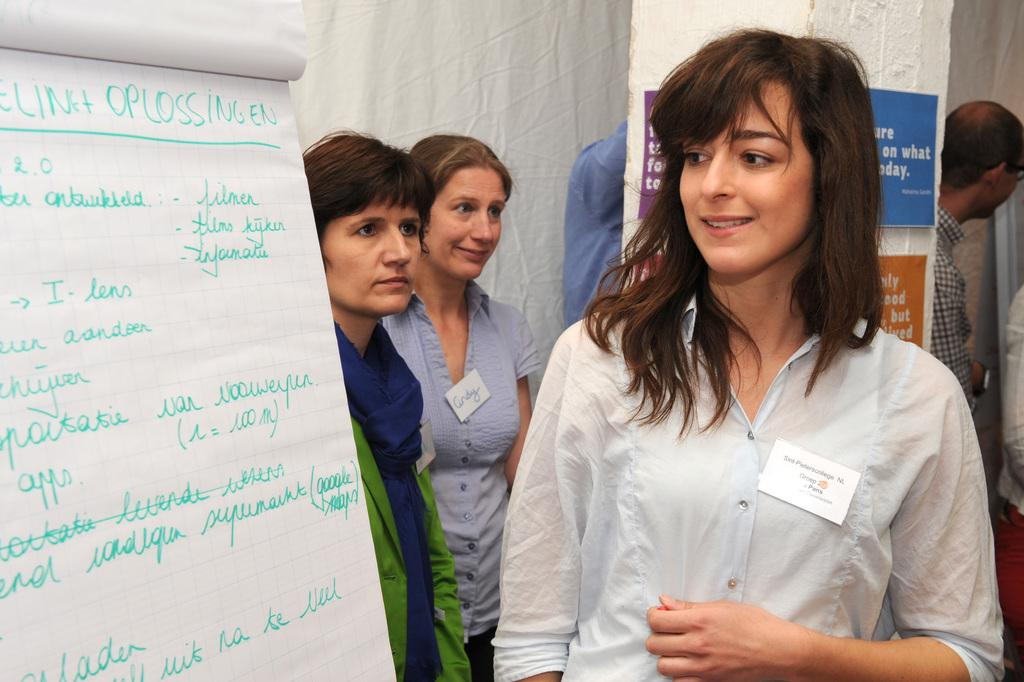Who is the main subject in the image? There is a lady in the image. What is located to the left side of the image? There is a paper with something written on it to the left side of the image. Can you describe the background of the image? There are people in the background of the image. What type of cream is being used to draw the shape in the image? There is no cream or shape being drawn in the image. 